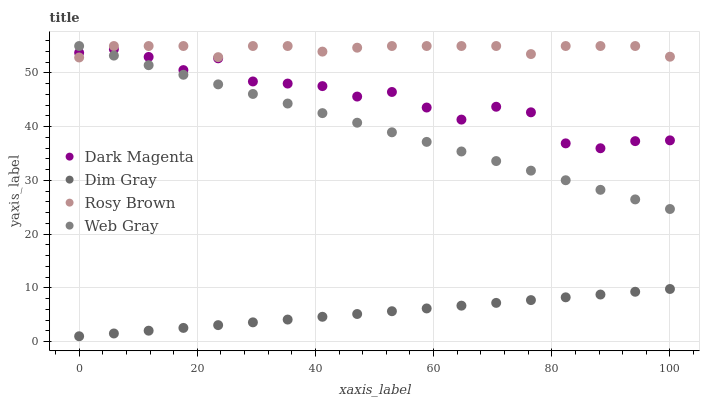Does Dim Gray have the minimum area under the curve?
Answer yes or no. Yes. Does Rosy Brown have the maximum area under the curve?
Answer yes or no. Yes. Does Web Gray have the minimum area under the curve?
Answer yes or no. No. Does Web Gray have the maximum area under the curve?
Answer yes or no. No. Is Dim Gray the smoothest?
Answer yes or no. Yes. Is Dark Magenta the roughest?
Answer yes or no. Yes. Is Web Gray the smoothest?
Answer yes or no. No. Is Web Gray the roughest?
Answer yes or no. No. Does Dim Gray have the lowest value?
Answer yes or no. Yes. Does Web Gray have the lowest value?
Answer yes or no. No. Does Web Gray have the highest value?
Answer yes or no. Yes. Does Dim Gray have the highest value?
Answer yes or no. No. Is Dim Gray less than Dark Magenta?
Answer yes or no. Yes. Is Web Gray greater than Dim Gray?
Answer yes or no. Yes. Does Dark Magenta intersect Rosy Brown?
Answer yes or no. Yes. Is Dark Magenta less than Rosy Brown?
Answer yes or no. No. Is Dark Magenta greater than Rosy Brown?
Answer yes or no. No. Does Dim Gray intersect Dark Magenta?
Answer yes or no. No. 